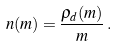Convert formula to latex. <formula><loc_0><loc_0><loc_500><loc_500>n ( m ) = \frac { \rho _ { d } ( m ) } { m } \, .</formula> 